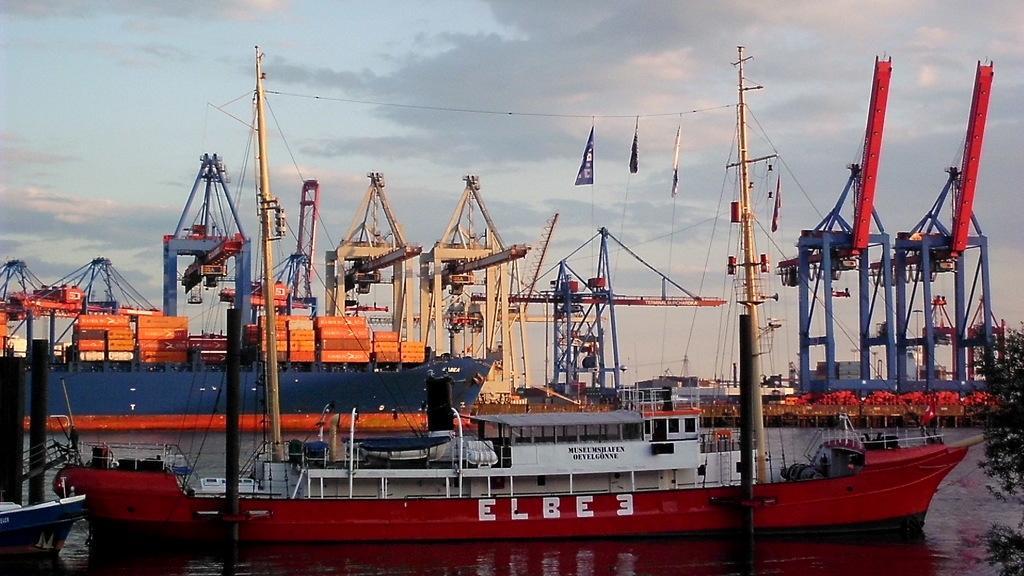Please provide a concise description of this image. At the bottom of the image there is water, above the water there are some ships. In the bottom right corner of the image there is a tree. 